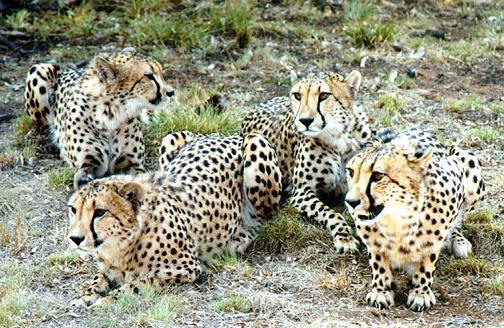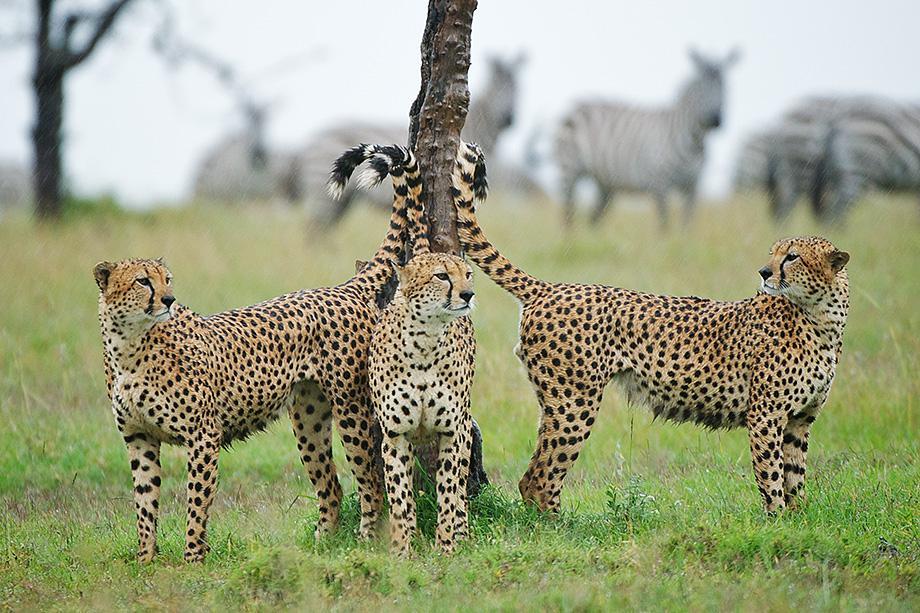The first image is the image on the left, the second image is the image on the right. Examine the images to the left and right. Is the description "The left image contains more cheetahs than the right image." accurate? Answer yes or no. Yes. The first image is the image on the left, the second image is the image on the right. Given the left and right images, does the statement "There are five animals in the image on the right." hold true? Answer yes or no. No. 